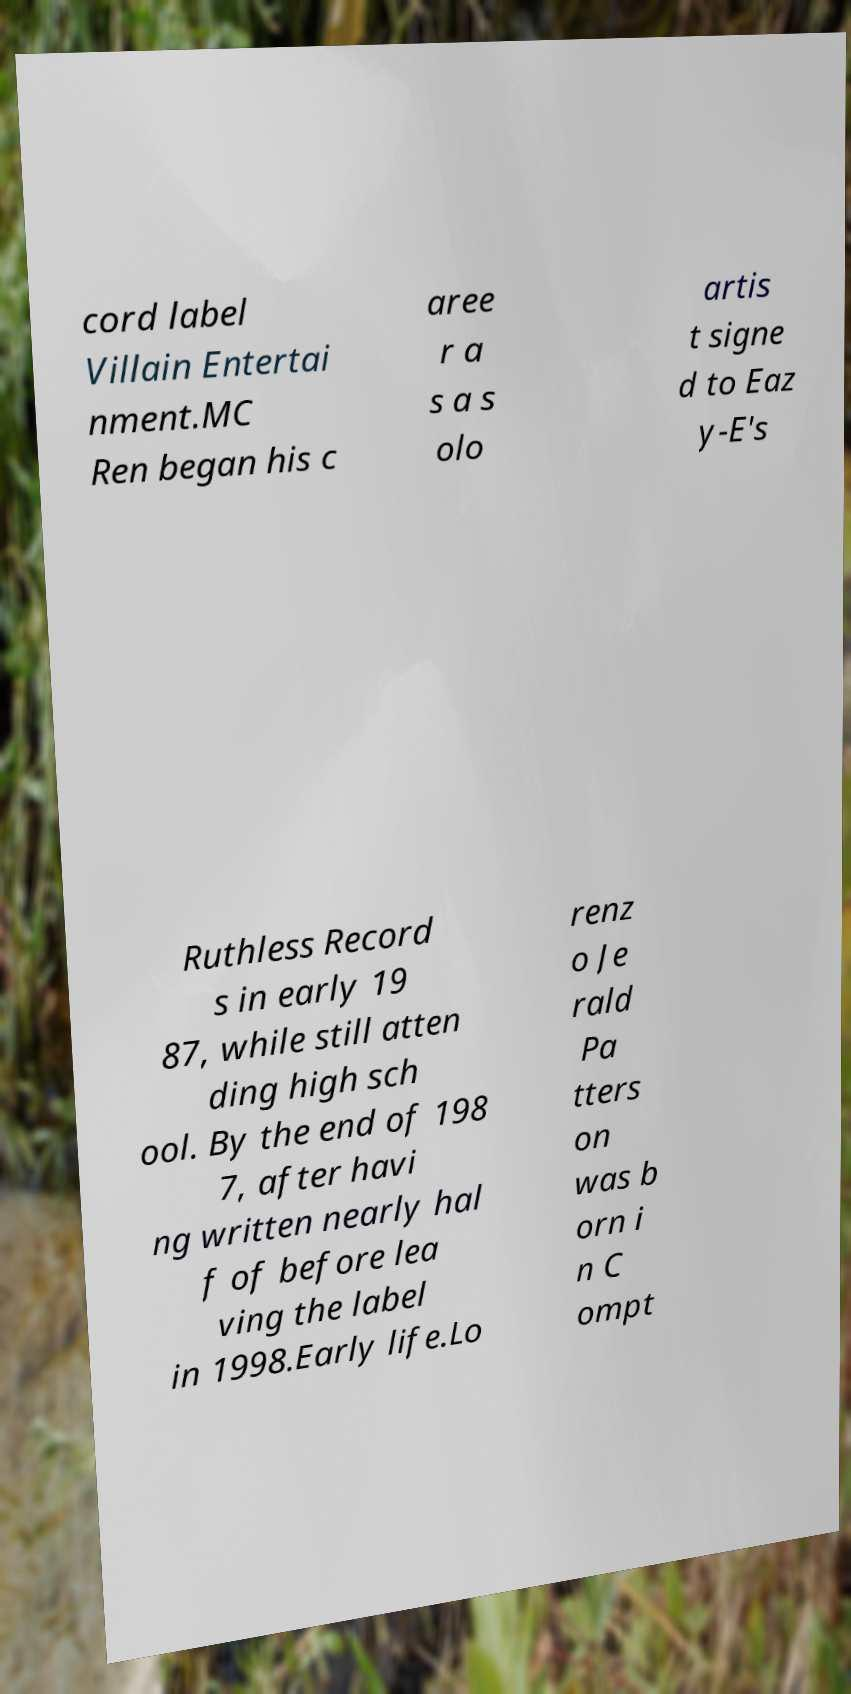There's text embedded in this image that I need extracted. Can you transcribe it verbatim? cord label Villain Entertai nment.MC Ren began his c aree r a s a s olo artis t signe d to Eaz y-E's Ruthless Record s in early 19 87, while still atten ding high sch ool. By the end of 198 7, after havi ng written nearly hal f of before lea ving the label in 1998.Early life.Lo renz o Je rald Pa tters on was b orn i n C ompt 